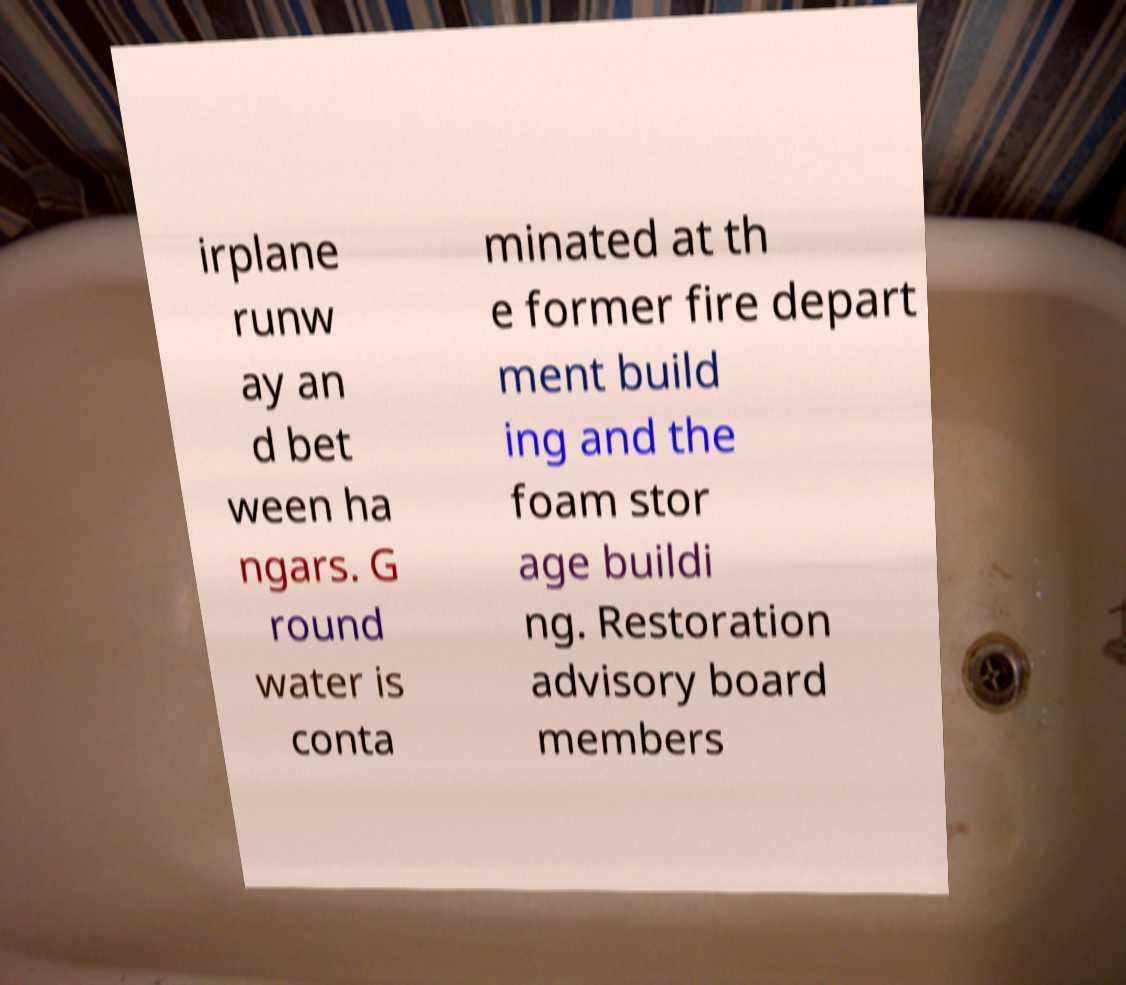Could you extract and type out the text from this image? irplane runw ay an d bet ween ha ngars. G round water is conta minated at th e former fire depart ment build ing and the foam stor age buildi ng. Restoration advisory board members 